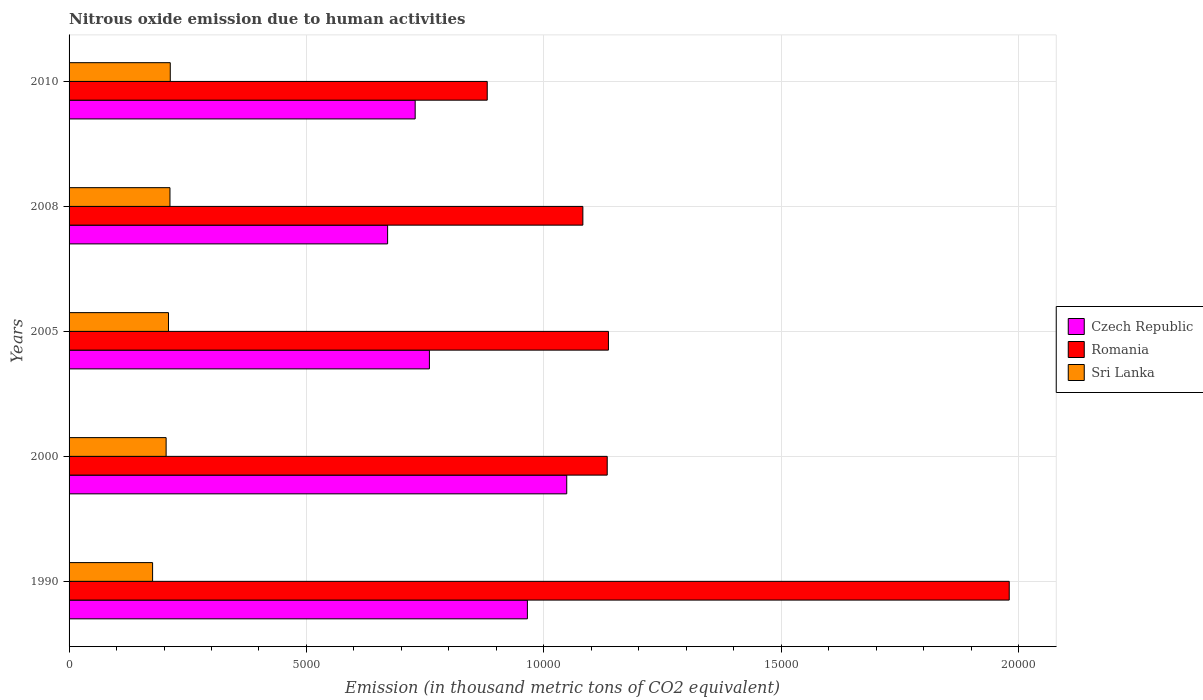What is the amount of nitrous oxide emitted in Sri Lanka in 1990?
Provide a short and direct response. 1759.4. Across all years, what is the maximum amount of nitrous oxide emitted in Sri Lanka?
Give a very brief answer. 2131.6. Across all years, what is the minimum amount of nitrous oxide emitted in Romania?
Offer a terse response. 8808.3. In which year was the amount of nitrous oxide emitted in Romania maximum?
Your answer should be very brief. 1990. What is the total amount of nitrous oxide emitted in Sri Lanka in the graph?
Give a very brief answer. 1.02e+04. What is the difference between the amount of nitrous oxide emitted in Romania in 2008 and that in 2010?
Your response must be concise. 2014.3. What is the difference between the amount of nitrous oxide emitted in Czech Republic in 1990 and the amount of nitrous oxide emitted in Sri Lanka in 2000?
Your response must be concise. 7609.5. What is the average amount of nitrous oxide emitted in Sri Lanka per year?
Provide a short and direct response. 2031. In the year 2005, what is the difference between the amount of nitrous oxide emitted in Sri Lanka and amount of nitrous oxide emitted in Romania?
Keep it short and to the point. -9267.3. In how many years, is the amount of nitrous oxide emitted in Romania greater than 12000 thousand metric tons?
Your response must be concise. 1. What is the ratio of the amount of nitrous oxide emitted in Sri Lanka in 1990 to that in 2010?
Your response must be concise. 0.83. What is the difference between the highest and the second highest amount of nitrous oxide emitted in Sri Lanka?
Give a very brief answer. 6.2. What is the difference between the highest and the lowest amount of nitrous oxide emitted in Romania?
Your answer should be very brief. 1.10e+04. In how many years, is the amount of nitrous oxide emitted in Romania greater than the average amount of nitrous oxide emitted in Romania taken over all years?
Give a very brief answer. 1. Is the sum of the amount of nitrous oxide emitted in Czech Republic in 2005 and 2008 greater than the maximum amount of nitrous oxide emitted in Romania across all years?
Offer a very short reply. No. What does the 1st bar from the top in 1990 represents?
Give a very brief answer. Sri Lanka. What does the 3rd bar from the bottom in 2005 represents?
Your answer should be compact. Sri Lanka. How many bars are there?
Ensure brevity in your answer.  15. Are all the bars in the graph horizontal?
Offer a very short reply. Yes. How many years are there in the graph?
Offer a terse response. 5. Does the graph contain any zero values?
Provide a short and direct response. No. Where does the legend appear in the graph?
Offer a terse response. Center right. How many legend labels are there?
Your response must be concise. 3. How are the legend labels stacked?
Your answer should be compact. Vertical. What is the title of the graph?
Offer a terse response. Nitrous oxide emission due to human activities. What is the label or title of the X-axis?
Your answer should be very brief. Emission (in thousand metric tons of CO2 equivalent). What is the label or title of the Y-axis?
Give a very brief answer. Years. What is the Emission (in thousand metric tons of CO2 equivalent) in Czech Republic in 1990?
Provide a short and direct response. 9654. What is the Emission (in thousand metric tons of CO2 equivalent) of Romania in 1990?
Ensure brevity in your answer.  1.98e+04. What is the Emission (in thousand metric tons of CO2 equivalent) in Sri Lanka in 1990?
Offer a terse response. 1759.4. What is the Emission (in thousand metric tons of CO2 equivalent) of Czech Republic in 2000?
Offer a very short reply. 1.05e+04. What is the Emission (in thousand metric tons of CO2 equivalent) in Romania in 2000?
Your response must be concise. 1.13e+04. What is the Emission (in thousand metric tons of CO2 equivalent) in Sri Lanka in 2000?
Your answer should be compact. 2044.5. What is the Emission (in thousand metric tons of CO2 equivalent) in Czech Republic in 2005?
Provide a short and direct response. 7590.3. What is the Emission (in thousand metric tons of CO2 equivalent) of Romania in 2005?
Offer a terse response. 1.14e+04. What is the Emission (in thousand metric tons of CO2 equivalent) of Sri Lanka in 2005?
Provide a succinct answer. 2094.1. What is the Emission (in thousand metric tons of CO2 equivalent) in Czech Republic in 2008?
Keep it short and to the point. 6709.7. What is the Emission (in thousand metric tons of CO2 equivalent) in Romania in 2008?
Give a very brief answer. 1.08e+04. What is the Emission (in thousand metric tons of CO2 equivalent) in Sri Lanka in 2008?
Offer a terse response. 2125.4. What is the Emission (in thousand metric tons of CO2 equivalent) of Czech Republic in 2010?
Provide a short and direct response. 7290.5. What is the Emission (in thousand metric tons of CO2 equivalent) in Romania in 2010?
Your answer should be very brief. 8808.3. What is the Emission (in thousand metric tons of CO2 equivalent) of Sri Lanka in 2010?
Your response must be concise. 2131.6. Across all years, what is the maximum Emission (in thousand metric tons of CO2 equivalent) in Czech Republic?
Offer a very short reply. 1.05e+04. Across all years, what is the maximum Emission (in thousand metric tons of CO2 equivalent) of Romania?
Offer a very short reply. 1.98e+04. Across all years, what is the maximum Emission (in thousand metric tons of CO2 equivalent) in Sri Lanka?
Your response must be concise. 2131.6. Across all years, what is the minimum Emission (in thousand metric tons of CO2 equivalent) of Czech Republic?
Make the answer very short. 6709.7. Across all years, what is the minimum Emission (in thousand metric tons of CO2 equivalent) of Romania?
Your answer should be compact. 8808.3. Across all years, what is the minimum Emission (in thousand metric tons of CO2 equivalent) of Sri Lanka?
Ensure brevity in your answer.  1759.4. What is the total Emission (in thousand metric tons of CO2 equivalent) of Czech Republic in the graph?
Your answer should be compact. 4.17e+04. What is the total Emission (in thousand metric tons of CO2 equivalent) in Romania in the graph?
Your answer should be very brief. 6.21e+04. What is the total Emission (in thousand metric tons of CO2 equivalent) in Sri Lanka in the graph?
Provide a succinct answer. 1.02e+04. What is the difference between the Emission (in thousand metric tons of CO2 equivalent) of Czech Republic in 1990 and that in 2000?
Keep it short and to the point. -829. What is the difference between the Emission (in thousand metric tons of CO2 equivalent) of Romania in 1990 and that in 2000?
Provide a short and direct response. 8468. What is the difference between the Emission (in thousand metric tons of CO2 equivalent) of Sri Lanka in 1990 and that in 2000?
Your response must be concise. -285.1. What is the difference between the Emission (in thousand metric tons of CO2 equivalent) in Czech Republic in 1990 and that in 2005?
Keep it short and to the point. 2063.7. What is the difference between the Emission (in thousand metric tons of CO2 equivalent) in Romania in 1990 and that in 2005?
Your answer should be compact. 8442.4. What is the difference between the Emission (in thousand metric tons of CO2 equivalent) of Sri Lanka in 1990 and that in 2005?
Make the answer very short. -334.7. What is the difference between the Emission (in thousand metric tons of CO2 equivalent) of Czech Republic in 1990 and that in 2008?
Give a very brief answer. 2944.3. What is the difference between the Emission (in thousand metric tons of CO2 equivalent) in Romania in 1990 and that in 2008?
Give a very brief answer. 8981.2. What is the difference between the Emission (in thousand metric tons of CO2 equivalent) in Sri Lanka in 1990 and that in 2008?
Your answer should be very brief. -366. What is the difference between the Emission (in thousand metric tons of CO2 equivalent) of Czech Republic in 1990 and that in 2010?
Make the answer very short. 2363.5. What is the difference between the Emission (in thousand metric tons of CO2 equivalent) of Romania in 1990 and that in 2010?
Offer a terse response. 1.10e+04. What is the difference between the Emission (in thousand metric tons of CO2 equivalent) of Sri Lanka in 1990 and that in 2010?
Offer a terse response. -372.2. What is the difference between the Emission (in thousand metric tons of CO2 equivalent) in Czech Republic in 2000 and that in 2005?
Make the answer very short. 2892.7. What is the difference between the Emission (in thousand metric tons of CO2 equivalent) of Romania in 2000 and that in 2005?
Offer a very short reply. -25.6. What is the difference between the Emission (in thousand metric tons of CO2 equivalent) of Sri Lanka in 2000 and that in 2005?
Offer a terse response. -49.6. What is the difference between the Emission (in thousand metric tons of CO2 equivalent) of Czech Republic in 2000 and that in 2008?
Your answer should be very brief. 3773.3. What is the difference between the Emission (in thousand metric tons of CO2 equivalent) of Romania in 2000 and that in 2008?
Ensure brevity in your answer.  513.2. What is the difference between the Emission (in thousand metric tons of CO2 equivalent) in Sri Lanka in 2000 and that in 2008?
Offer a very short reply. -80.9. What is the difference between the Emission (in thousand metric tons of CO2 equivalent) in Czech Republic in 2000 and that in 2010?
Your answer should be compact. 3192.5. What is the difference between the Emission (in thousand metric tons of CO2 equivalent) of Romania in 2000 and that in 2010?
Offer a terse response. 2527.5. What is the difference between the Emission (in thousand metric tons of CO2 equivalent) of Sri Lanka in 2000 and that in 2010?
Provide a short and direct response. -87.1. What is the difference between the Emission (in thousand metric tons of CO2 equivalent) of Czech Republic in 2005 and that in 2008?
Keep it short and to the point. 880.6. What is the difference between the Emission (in thousand metric tons of CO2 equivalent) in Romania in 2005 and that in 2008?
Offer a terse response. 538.8. What is the difference between the Emission (in thousand metric tons of CO2 equivalent) in Sri Lanka in 2005 and that in 2008?
Offer a very short reply. -31.3. What is the difference between the Emission (in thousand metric tons of CO2 equivalent) in Czech Republic in 2005 and that in 2010?
Give a very brief answer. 299.8. What is the difference between the Emission (in thousand metric tons of CO2 equivalent) of Romania in 2005 and that in 2010?
Offer a very short reply. 2553.1. What is the difference between the Emission (in thousand metric tons of CO2 equivalent) in Sri Lanka in 2005 and that in 2010?
Provide a succinct answer. -37.5. What is the difference between the Emission (in thousand metric tons of CO2 equivalent) in Czech Republic in 2008 and that in 2010?
Ensure brevity in your answer.  -580.8. What is the difference between the Emission (in thousand metric tons of CO2 equivalent) in Romania in 2008 and that in 2010?
Offer a very short reply. 2014.3. What is the difference between the Emission (in thousand metric tons of CO2 equivalent) in Sri Lanka in 2008 and that in 2010?
Provide a succinct answer. -6.2. What is the difference between the Emission (in thousand metric tons of CO2 equivalent) of Czech Republic in 1990 and the Emission (in thousand metric tons of CO2 equivalent) of Romania in 2000?
Your response must be concise. -1681.8. What is the difference between the Emission (in thousand metric tons of CO2 equivalent) in Czech Republic in 1990 and the Emission (in thousand metric tons of CO2 equivalent) in Sri Lanka in 2000?
Your answer should be compact. 7609.5. What is the difference between the Emission (in thousand metric tons of CO2 equivalent) in Romania in 1990 and the Emission (in thousand metric tons of CO2 equivalent) in Sri Lanka in 2000?
Provide a succinct answer. 1.78e+04. What is the difference between the Emission (in thousand metric tons of CO2 equivalent) in Czech Republic in 1990 and the Emission (in thousand metric tons of CO2 equivalent) in Romania in 2005?
Give a very brief answer. -1707.4. What is the difference between the Emission (in thousand metric tons of CO2 equivalent) of Czech Republic in 1990 and the Emission (in thousand metric tons of CO2 equivalent) of Sri Lanka in 2005?
Your response must be concise. 7559.9. What is the difference between the Emission (in thousand metric tons of CO2 equivalent) in Romania in 1990 and the Emission (in thousand metric tons of CO2 equivalent) in Sri Lanka in 2005?
Offer a terse response. 1.77e+04. What is the difference between the Emission (in thousand metric tons of CO2 equivalent) of Czech Republic in 1990 and the Emission (in thousand metric tons of CO2 equivalent) of Romania in 2008?
Ensure brevity in your answer.  -1168.6. What is the difference between the Emission (in thousand metric tons of CO2 equivalent) in Czech Republic in 1990 and the Emission (in thousand metric tons of CO2 equivalent) in Sri Lanka in 2008?
Provide a succinct answer. 7528.6. What is the difference between the Emission (in thousand metric tons of CO2 equivalent) of Romania in 1990 and the Emission (in thousand metric tons of CO2 equivalent) of Sri Lanka in 2008?
Your answer should be compact. 1.77e+04. What is the difference between the Emission (in thousand metric tons of CO2 equivalent) in Czech Republic in 1990 and the Emission (in thousand metric tons of CO2 equivalent) in Romania in 2010?
Make the answer very short. 845.7. What is the difference between the Emission (in thousand metric tons of CO2 equivalent) in Czech Republic in 1990 and the Emission (in thousand metric tons of CO2 equivalent) in Sri Lanka in 2010?
Make the answer very short. 7522.4. What is the difference between the Emission (in thousand metric tons of CO2 equivalent) in Romania in 1990 and the Emission (in thousand metric tons of CO2 equivalent) in Sri Lanka in 2010?
Give a very brief answer. 1.77e+04. What is the difference between the Emission (in thousand metric tons of CO2 equivalent) in Czech Republic in 2000 and the Emission (in thousand metric tons of CO2 equivalent) in Romania in 2005?
Keep it short and to the point. -878.4. What is the difference between the Emission (in thousand metric tons of CO2 equivalent) in Czech Republic in 2000 and the Emission (in thousand metric tons of CO2 equivalent) in Sri Lanka in 2005?
Your answer should be very brief. 8388.9. What is the difference between the Emission (in thousand metric tons of CO2 equivalent) of Romania in 2000 and the Emission (in thousand metric tons of CO2 equivalent) of Sri Lanka in 2005?
Give a very brief answer. 9241.7. What is the difference between the Emission (in thousand metric tons of CO2 equivalent) of Czech Republic in 2000 and the Emission (in thousand metric tons of CO2 equivalent) of Romania in 2008?
Keep it short and to the point. -339.6. What is the difference between the Emission (in thousand metric tons of CO2 equivalent) of Czech Republic in 2000 and the Emission (in thousand metric tons of CO2 equivalent) of Sri Lanka in 2008?
Your response must be concise. 8357.6. What is the difference between the Emission (in thousand metric tons of CO2 equivalent) in Romania in 2000 and the Emission (in thousand metric tons of CO2 equivalent) in Sri Lanka in 2008?
Provide a succinct answer. 9210.4. What is the difference between the Emission (in thousand metric tons of CO2 equivalent) of Czech Republic in 2000 and the Emission (in thousand metric tons of CO2 equivalent) of Romania in 2010?
Ensure brevity in your answer.  1674.7. What is the difference between the Emission (in thousand metric tons of CO2 equivalent) of Czech Republic in 2000 and the Emission (in thousand metric tons of CO2 equivalent) of Sri Lanka in 2010?
Provide a short and direct response. 8351.4. What is the difference between the Emission (in thousand metric tons of CO2 equivalent) of Romania in 2000 and the Emission (in thousand metric tons of CO2 equivalent) of Sri Lanka in 2010?
Offer a very short reply. 9204.2. What is the difference between the Emission (in thousand metric tons of CO2 equivalent) of Czech Republic in 2005 and the Emission (in thousand metric tons of CO2 equivalent) of Romania in 2008?
Provide a short and direct response. -3232.3. What is the difference between the Emission (in thousand metric tons of CO2 equivalent) of Czech Republic in 2005 and the Emission (in thousand metric tons of CO2 equivalent) of Sri Lanka in 2008?
Your answer should be compact. 5464.9. What is the difference between the Emission (in thousand metric tons of CO2 equivalent) in Romania in 2005 and the Emission (in thousand metric tons of CO2 equivalent) in Sri Lanka in 2008?
Provide a short and direct response. 9236. What is the difference between the Emission (in thousand metric tons of CO2 equivalent) in Czech Republic in 2005 and the Emission (in thousand metric tons of CO2 equivalent) in Romania in 2010?
Keep it short and to the point. -1218. What is the difference between the Emission (in thousand metric tons of CO2 equivalent) of Czech Republic in 2005 and the Emission (in thousand metric tons of CO2 equivalent) of Sri Lanka in 2010?
Offer a very short reply. 5458.7. What is the difference between the Emission (in thousand metric tons of CO2 equivalent) of Romania in 2005 and the Emission (in thousand metric tons of CO2 equivalent) of Sri Lanka in 2010?
Your answer should be very brief. 9229.8. What is the difference between the Emission (in thousand metric tons of CO2 equivalent) in Czech Republic in 2008 and the Emission (in thousand metric tons of CO2 equivalent) in Romania in 2010?
Offer a very short reply. -2098.6. What is the difference between the Emission (in thousand metric tons of CO2 equivalent) of Czech Republic in 2008 and the Emission (in thousand metric tons of CO2 equivalent) of Sri Lanka in 2010?
Offer a very short reply. 4578.1. What is the difference between the Emission (in thousand metric tons of CO2 equivalent) of Romania in 2008 and the Emission (in thousand metric tons of CO2 equivalent) of Sri Lanka in 2010?
Ensure brevity in your answer.  8691. What is the average Emission (in thousand metric tons of CO2 equivalent) in Czech Republic per year?
Give a very brief answer. 8345.5. What is the average Emission (in thousand metric tons of CO2 equivalent) in Romania per year?
Keep it short and to the point. 1.24e+04. What is the average Emission (in thousand metric tons of CO2 equivalent) of Sri Lanka per year?
Your response must be concise. 2031. In the year 1990, what is the difference between the Emission (in thousand metric tons of CO2 equivalent) of Czech Republic and Emission (in thousand metric tons of CO2 equivalent) of Romania?
Your answer should be compact. -1.01e+04. In the year 1990, what is the difference between the Emission (in thousand metric tons of CO2 equivalent) of Czech Republic and Emission (in thousand metric tons of CO2 equivalent) of Sri Lanka?
Provide a succinct answer. 7894.6. In the year 1990, what is the difference between the Emission (in thousand metric tons of CO2 equivalent) in Romania and Emission (in thousand metric tons of CO2 equivalent) in Sri Lanka?
Your answer should be compact. 1.80e+04. In the year 2000, what is the difference between the Emission (in thousand metric tons of CO2 equivalent) of Czech Republic and Emission (in thousand metric tons of CO2 equivalent) of Romania?
Provide a succinct answer. -852.8. In the year 2000, what is the difference between the Emission (in thousand metric tons of CO2 equivalent) in Czech Republic and Emission (in thousand metric tons of CO2 equivalent) in Sri Lanka?
Ensure brevity in your answer.  8438.5. In the year 2000, what is the difference between the Emission (in thousand metric tons of CO2 equivalent) in Romania and Emission (in thousand metric tons of CO2 equivalent) in Sri Lanka?
Your answer should be very brief. 9291.3. In the year 2005, what is the difference between the Emission (in thousand metric tons of CO2 equivalent) in Czech Republic and Emission (in thousand metric tons of CO2 equivalent) in Romania?
Keep it short and to the point. -3771.1. In the year 2005, what is the difference between the Emission (in thousand metric tons of CO2 equivalent) of Czech Republic and Emission (in thousand metric tons of CO2 equivalent) of Sri Lanka?
Your answer should be very brief. 5496.2. In the year 2005, what is the difference between the Emission (in thousand metric tons of CO2 equivalent) of Romania and Emission (in thousand metric tons of CO2 equivalent) of Sri Lanka?
Your answer should be compact. 9267.3. In the year 2008, what is the difference between the Emission (in thousand metric tons of CO2 equivalent) in Czech Republic and Emission (in thousand metric tons of CO2 equivalent) in Romania?
Offer a terse response. -4112.9. In the year 2008, what is the difference between the Emission (in thousand metric tons of CO2 equivalent) of Czech Republic and Emission (in thousand metric tons of CO2 equivalent) of Sri Lanka?
Offer a terse response. 4584.3. In the year 2008, what is the difference between the Emission (in thousand metric tons of CO2 equivalent) of Romania and Emission (in thousand metric tons of CO2 equivalent) of Sri Lanka?
Provide a succinct answer. 8697.2. In the year 2010, what is the difference between the Emission (in thousand metric tons of CO2 equivalent) of Czech Republic and Emission (in thousand metric tons of CO2 equivalent) of Romania?
Provide a short and direct response. -1517.8. In the year 2010, what is the difference between the Emission (in thousand metric tons of CO2 equivalent) in Czech Republic and Emission (in thousand metric tons of CO2 equivalent) in Sri Lanka?
Give a very brief answer. 5158.9. In the year 2010, what is the difference between the Emission (in thousand metric tons of CO2 equivalent) of Romania and Emission (in thousand metric tons of CO2 equivalent) of Sri Lanka?
Your answer should be very brief. 6676.7. What is the ratio of the Emission (in thousand metric tons of CO2 equivalent) in Czech Republic in 1990 to that in 2000?
Your answer should be compact. 0.92. What is the ratio of the Emission (in thousand metric tons of CO2 equivalent) of Romania in 1990 to that in 2000?
Give a very brief answer. 1.75. What is the ratio of the Emission (in thousand metric tons of CO2 equivalent) of Sri Lanka in 1990 to that in 2000?
Your answer should be compact. 0.86. What is the ratio of the Emission (in thousand metric tons of CO2 equivalent) in Czech Republic in 1990 to that in 2005?
Offer a terse response. 1.27. What is the ratio of the Emission (in thousand metric tons of CO2 equivalent) in Romania in 1990 to that in 2005?
Provide a succinct answer. 1.74. What is the ratio of the Emission (in thousand metric tons of CO2 equivalent) in Sri Lanka in 1990 to that in 2005?
Keep it short and to the point. 0.84. What is the ratio of the Emission (in thousand metric tons of CO2 equivalent) in Czech Republic in 1990 to that in 2008?
Offer a very short reply. 1.44. What is the ratio of the Emission (in thousand metric tons of CO2 equivalent) in Romania in 1990 to that in 2008?
Your answer should be compact. 1.83. What is the ratio of the Emission (in thousand metric tons of CO2 equivalent) of Sri Lanka in 1990 to that in 2008?
Make the answer very short. 0.83. What is the ratio of the Emission (in thousand metric tons of CO2 equivalent) in Czech Republic in 1990 to that in 2010?
Offer a terse response. 1.32. What is the ratio of the Emission (in thousand metric tons of CO2 equivalent) in Romania in 1990 to that in 2010?
Provide a succinct answer. 2.25. What is the ratio of the Emission (in thousand metric tons of CO2 equivalent) in Sri Lanka in 1990 to that in 2010?
Offer a very short reply. 0.83. What is the ratio of the Emission (in thousand metric tons of CO2 equivalent) in Czech Republic in 2000 to that in 2005?
Your answer should be compact. 1.38. What is the ratio of the Emission (in thousand metric tons of CO2 equivalent) of Sri Lanka in 2000 to that in 2005?
Your response must be concise. 0.98. What is the ratio of the Emission (in thousand metric tons of CO2 equivalent) of Czech Republic in 2000 to that in 2008?
Offer a terse response. 1.56. What is the ratio of the Emission (in thousand metric tons of CO2 equivalent) of Romania in 2000 to that in 2008?
Provide a short and direct response. 1.05. What is the ratio of the Emission (in thousand metric tons of CO2 equivalent) of Sri Lanka in 2000 to that in 2008?
Your answer should be compact. 0.96. What is the ratio of the Emission (in thousand metric tons of CO2 equivalent) in Czech Republic in 2000 to that in 2010?
Provide a succinct answer. 1.44. What is the ratio of the Emission (in thousand metric tons of CO2 equivalent) of Romania in 2000 to that in 2010?
Offer a very short reply. 1.29. What is the ratio of the Emission (in thousand metric tons of CO2 equivalent) in Sri Lanka in 2000 to that in 2010?
Ensure brevity in your answer.  0.96. What is the ratio of the Emission (in thousand metric tons of CO2 equivalent) of Czech Republic in 2005 to that in 2008?
Your answer should be compact. 1.13. What is the ratio of the Emission (in thousand metric tons of CO2 equivalent) in Romania in 2005 to that in 2008?
Ensure brevity in your answer.  1.05. What is the ratio of the Emission (in thousand metric tons of CO2 equivalent) in Czech Republic in 2005 to that in 2010?
Your answer should be compact. 1.04. What is the ratio of the Emission (in thousand metric tons of CO2 equivalent) in Romania in 2005 to that in 2010?
Keep it short and to the point. 1.29. What is the ratio of the Emission (in thousand metric tons of CO2 equivalent) of Sri Lanka in 2005 to that in 2010?
Give a very brief answer. 0.98. What is the ratio of the Emission (in thousand metric tons of CO2 equivalent) of Czech Republic in 2008 to that in 2010?
Your response must be concise. 0.92. What is the ratio of the Emission (in thousand metric tons of CO2 equivalent) of Romania in 2008 to that in 2010?
Offer a terse response. 1.23. What is the difference between the highest and the second highest Emission (in thousand metric tons of CO2 equivalent) in Czech Republic?
Provide a short and direct response. 829. What is the difference between the highest and the second highest Emission (in thousand metric tons of CO2 equivalent) of Romania?
Ensure brevity in your answer.  8442.4. What is the difference between the highest and the second highest Emission (in thousand metric tons of CO2 equivalent) of Sri Lanka?
Provide a short and direct response. 6.2. What is the difference between the highest and the lowest Emission (in thousand metric tons of CO2 equivalent) of Czech Republic?
Keep it short and to the point. 3773.3. What is the difference between the highest and the lowest Emission (in thousand metric tons of CO2 equivalent) in Romania?
Offer a terse response. 1.10e+04. What is the difference between the highest and the lowest Emission (in thousand metric tons of CO2 equivalent) in Sri Lanka?
Offer a very short reply. 372.2. 